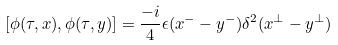Convert formula to latex. <formula><loc_0><loc_0><loc_500><loc_500>\left [ \phi ( \tau , x ) , \phi ( \tau , y ) \right ] = \frac { - i } { 4 } \epsilon ( x ^ { - } - y ^ { - } ) \delta ^ { 2 } ( x ^ { \perp } - y ^ { \perp } )</formula> 